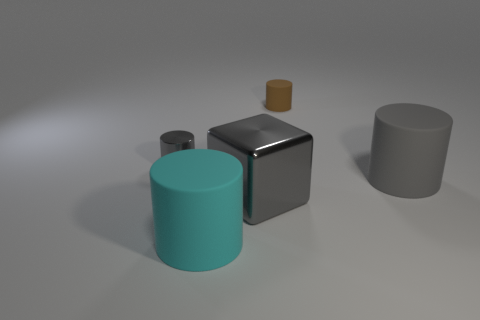Is the material of the big cube that is right of the gray metal cylinder the same as the brown cylinder?
Your answer should be compact. No. How many tiny objects are blue blocks or cyan matte objects?
Ensure brevity in your answer.  0. The gray block is what size?
Make the answer very short. Large. There is a gray rubber cylinder; is its size the same as the shiny thing to the right of the metallic cylinder?
Ensure brevity in your answer.  Yes. What number of purple things are either large matte things or large metal things?
Give a very brief answer. 0. How many large brown shiny cylinders are there?
Keep it short and to the point. 0. There is a gray object that is on the right side of the brown cylinder; what is its size?
Your answer should be compact. Large. Does the metallic cylinder have the same size as the gray matte cylinder?
Your response must be concise. No. What number of objects are small yellow objects or tiny objects to the left of the large cyan matte cylinder?
Provide a succinct answer. 1. What is the material of the cyan object?
Keep it short and to the point. Rubber. 